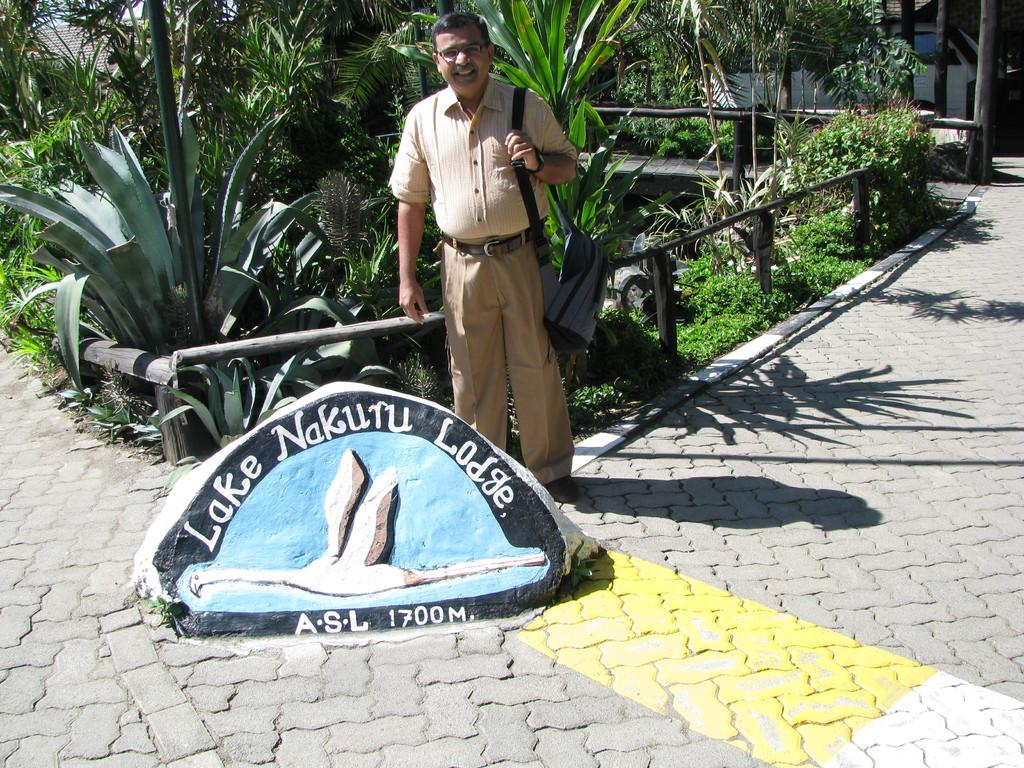What is the man in the image doing? The man is standing in the image. What is the man wearing? The man is wearing a shirt. What is the man holding in the image? The man is holding a bag. What can be seen in front of the man? There is a rock painting in front of the man. What is visible behind the man? There is fencing behind the man. What type of natural elements are present in the image? Plants are present in the image. What type of brass instrument is the man playing in the image? There is no brass instrument present in the image; the man is holding a bag and standing near a rock painting. 